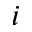Convert formula to latex. <formula><loc_0><loc_0><loc_500><loc_500>i</formula> 